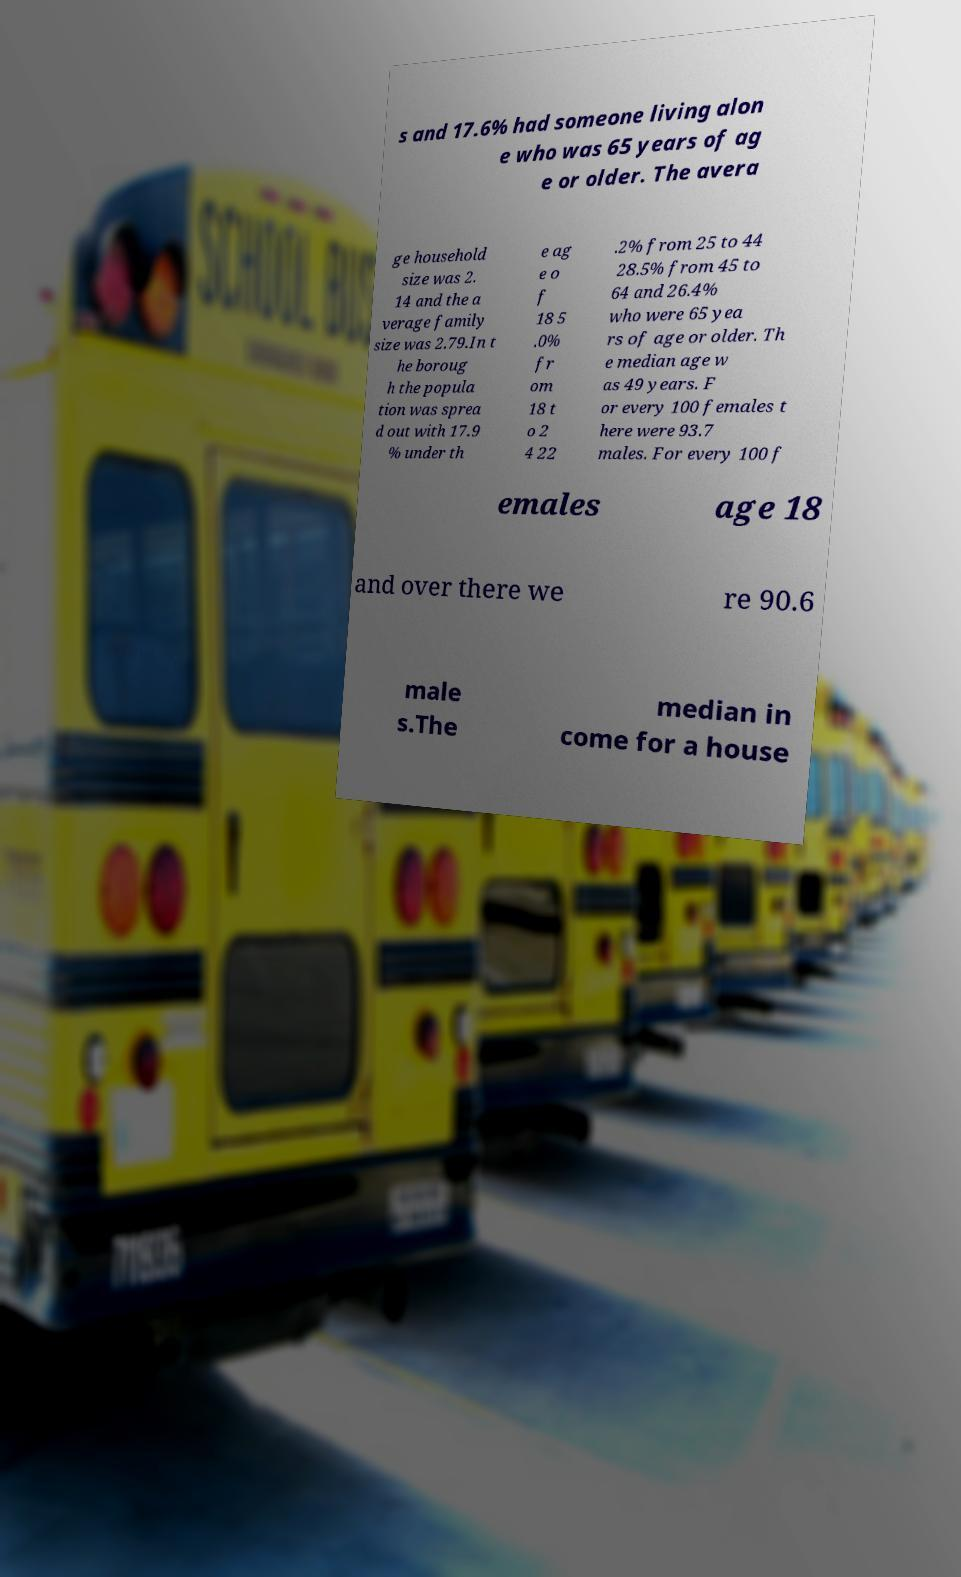What messages or text are displayed in this image? I need them in a readable, typed format. s and 17.6% had someone living alon e who was 65 years of ag e or older. The avera ge household size was 2. 14 and the a verage family size was 2.79.In t he boroug h the popula tion was sprea d out with 17.9 % under th e ag e o f 18 5 .0% fr om 18 t o 2 4 22 .2% from 25 to 44 28.5% from 45 to 64 and 26.4% who were 65 yea rs of age or older. Th e median age w as 49 years. F or every 100 females t here were 93.7 males. For every 100 f emales age 18 and over there we re 90.6 male s.The median in come for a house 